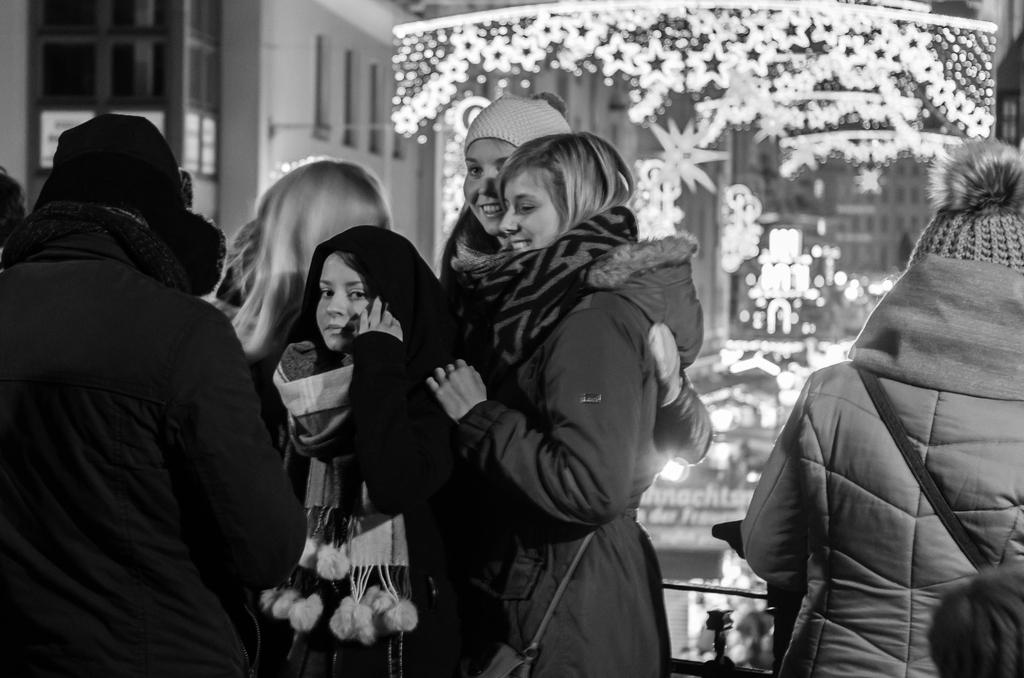How many people are in the image? There are persons in the image, but the exact number is not specified. What are the persons wearing in the image? The persons are wearing sweaters or shrugs in the image. What are the persons doing in the image? The persons are standing in the image. What can be seen in the background of the image? There are lights and a wall in the background of the image. Who is the aunt in the image? There is no mention of an aunt in the image. 